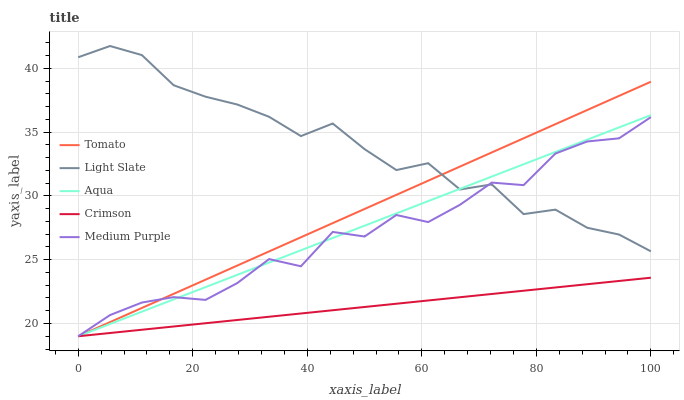Does Crimson have the minimum area under the curve?
Answer yes or no. Yes. Does Light Slate have the maximum area under the curve?
Answer yes or no. Yes. Does Medium Purple have the minimum area under the curve?
Answer yes or no. No. Does Medium Purple have the maximum area under the curve?
Answer yes or no. No. Is Crimson the smoothest?
Answer yes or no. Yes. Is Light Slate the roughest?
Answer yes or no. Yes. Is Medium Purple the smoothest?
Answer yes or no. No. Is Medium Purple the roughest?
Answer yes or no. No. Does Tomato have the lowest value?
Answer yes or no. Yes. Does Light Slate have the lowest value?
Answer yes or no. No. Does Light Slate have the highest value?
Answer yes or no. Yes. Does Medium Purple have the highest value?
Answer yes or no. No. Is Crimson less than Light Slate?
Answer yes or no. Yes. Is Light Slate greater than Crimson?
Answer yes or no. Yes. Does Medium Purple intersect Crimson?
Answer yes or no. Yes. Is Medium Purple less than Crimson?
Answer yes or no. No. Is Medium Purple greater than Crimson?
Answer yes or no. No. Does Crimson intersect Light Slate?
Answer yes or no. No. 